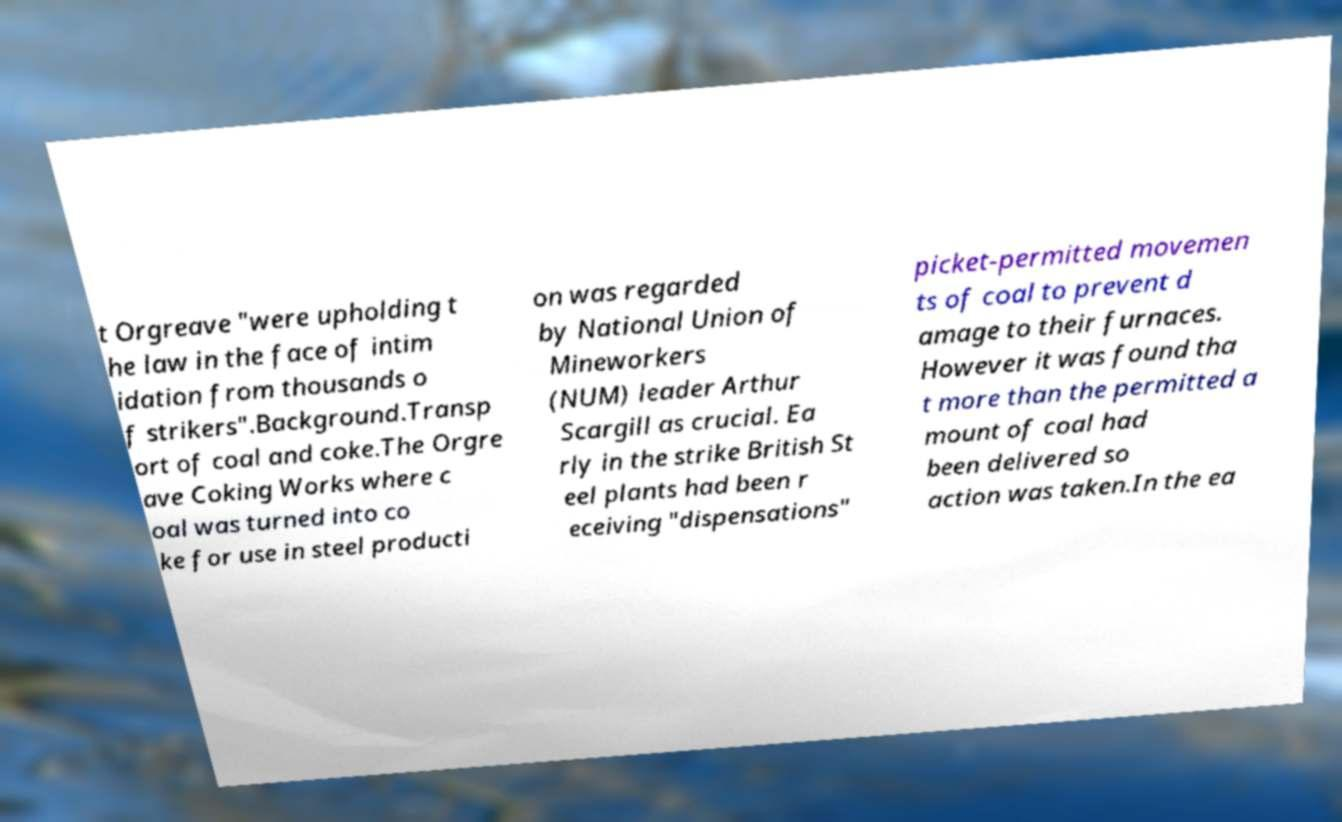Please read and relay the text visible in this image. What does it say? t Orgreave "were upholding t he law in the face of intim idation from thousands o f strikers".Background.Transp ort of coal and coke.The Orgre ave Coking Works where c oal was turned into co ke for use in steel producti on was regarded by National Union of Mineworkers (NUM) leader Arthur Scargill as crucial. Ea rly in the strike British St eel plants had been r eceiving "dispensations" picket-permitted movemen ts of coal to prevent d amage to their furnaces. However it was found tha t more than the permitted a mount of coal had been delivered so action was taken.In the ea 